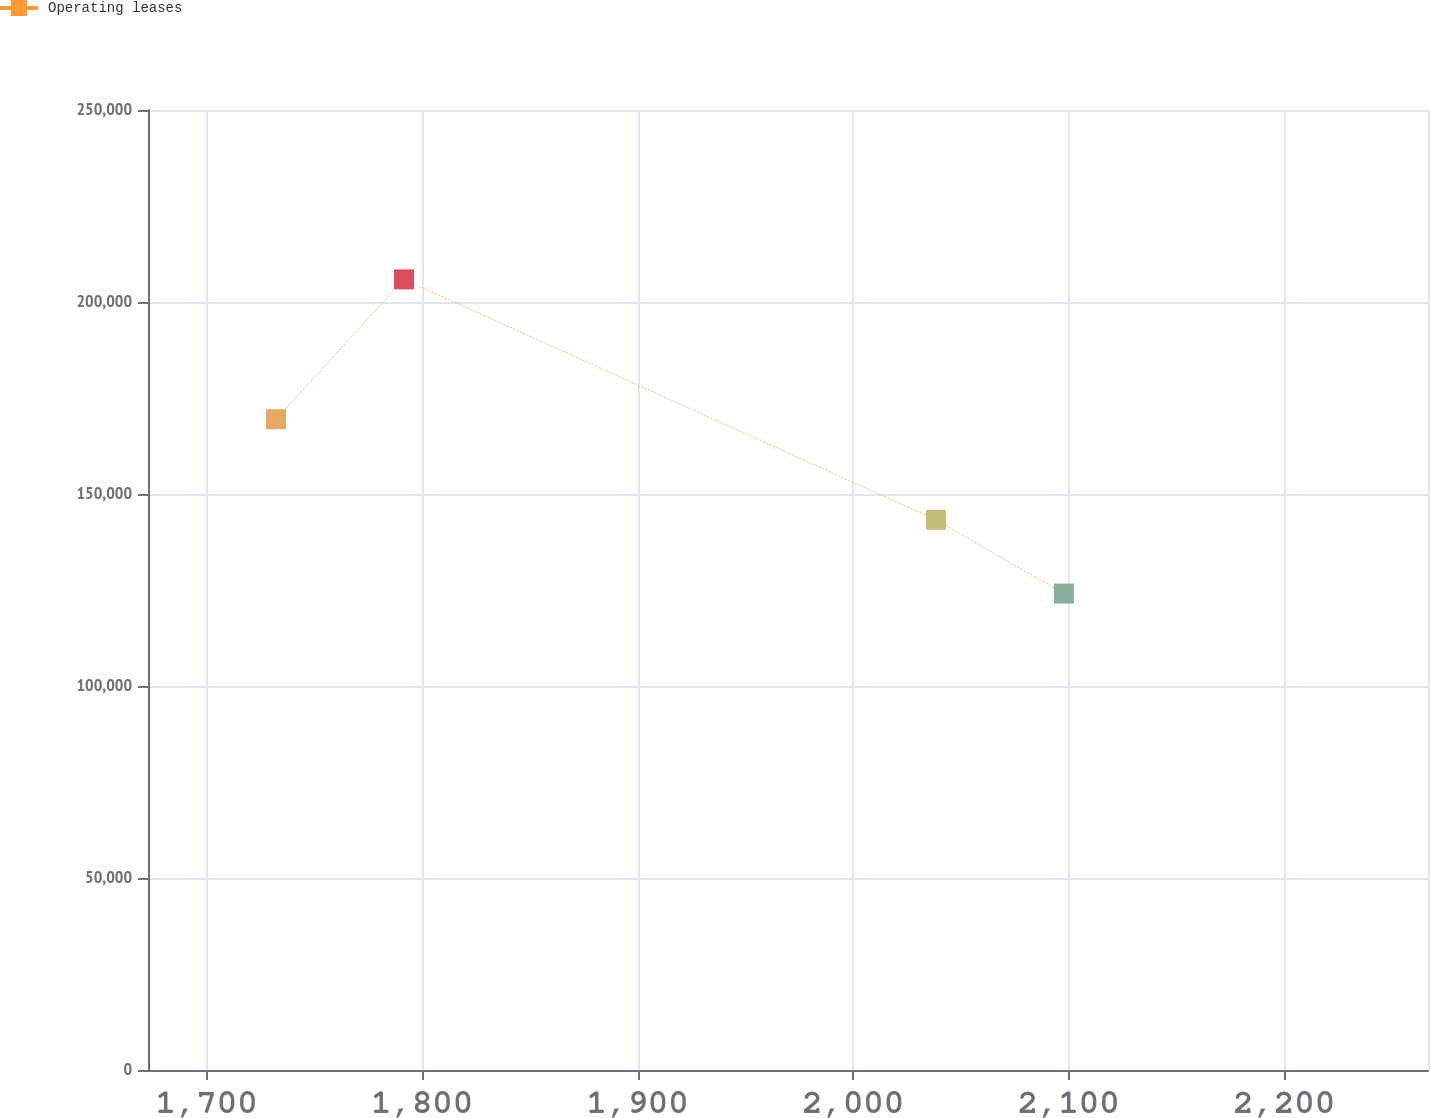<chart> <loc_0><loc_0><loc_500><loc_500><line_chart><ecel><fcel>Operating leases<nl><fcel>1732.21<fcel>169471<nl><fcel>1791.6<fcel>205894<nl><fcel>2038.41<fcel>143285<nl><fcel>2097.8<fcel>124069<nl><fcel>2326.13<fcel>106571<nl></chart> 